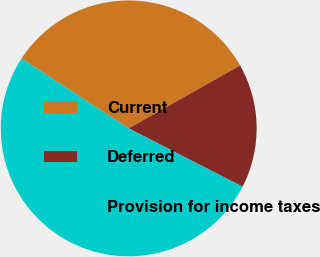Convert chart to OTSL. <chart><loc_0><loc_0><loc_500><loc_500><pie_chart><fcel>Current<fcel>Deferred<fcel>Provision for income taxes<nl><fcel>32.62%<fcel>15.72%<fcel>51.67%<nl></chart> 